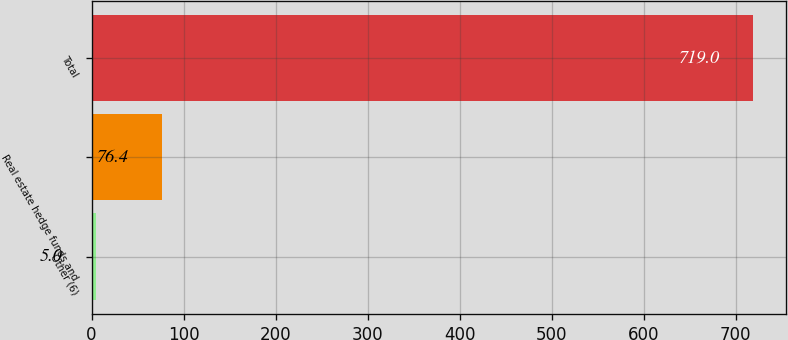Convert chart to OTSL. <chart><loc_0><loc_0><loc_500><loc_500><bar_chart><fcel>Other (6)<fcel>Real estate hedge funds and<fcel>Total<nl><fcel>5<fcel>76.4<fcel>719<nl></chart> 